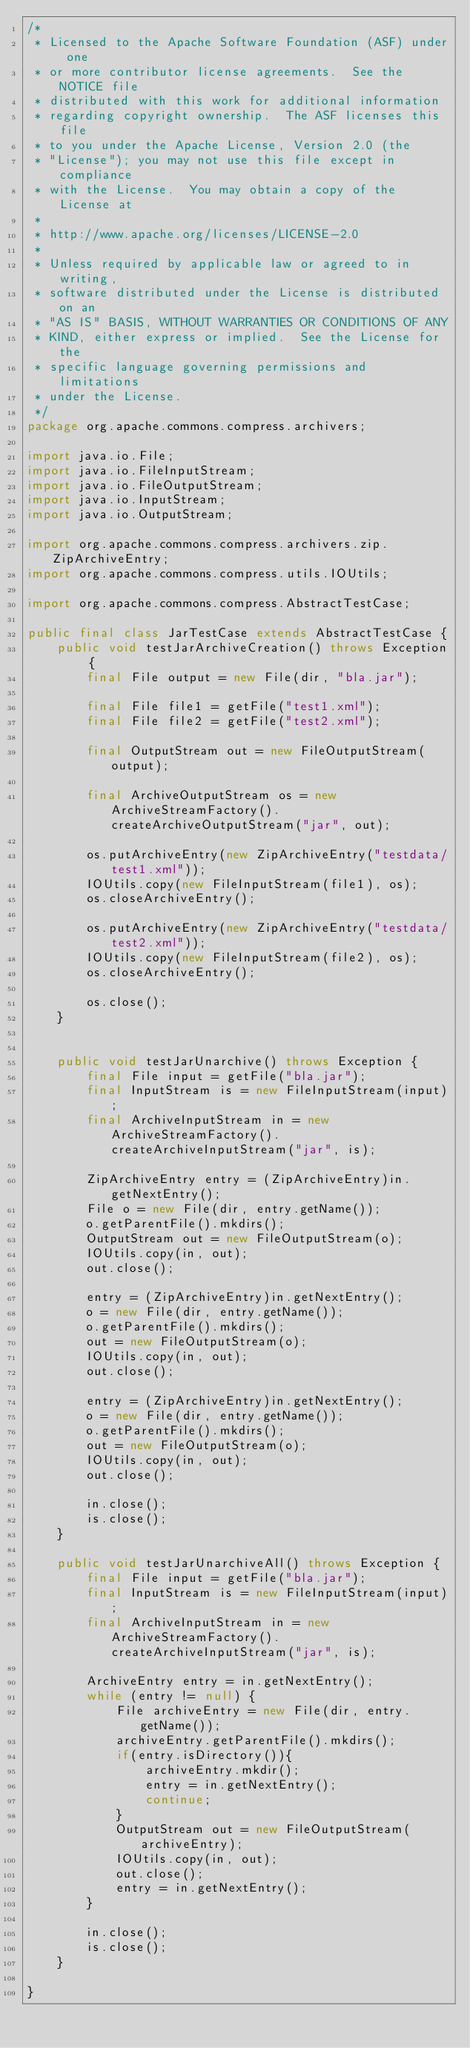<code> <loc_0><loc_0><loc_500><loc_500><_Java_>/*
 * Licensed to the Apache Software Foundation (ASF) under one
 * or more contributor license agreements.  See the NOTICE file
 * distributed with this work for additional information
 * regarding copyright ownership.  The ASF licenses this file
 * to you under the Apache License, Version 2.0 (the
 * "License"); you may not use this file except in compliance
 * with the License.  You may obtain a copy of the License at
 *
 * http://www.apache.org/licenses/LICENSE-2.0
 *
 * Unless required by applicable law or agreed to in writing,
 * software distributed under the License is distributed on an
 * "AS IS" BASIS, WITHOUT WARRANTIES OR CONDITIONS OF ANY
 * KIND, either express or implied.  See the License for the
 * specific language governing permissions and limitations
 * under the License.
 */
package org.apache.commons.compress.archivers;

import java.io.File;
import java.io.FileInputStream;
import java.io.FileOutputStream;
import java.io.InputStream;
import java.io.OutputStream;

import org.apache.commons.compress.archivers.zip.ZipArchiveEntry;
import org.apache.commons.compress.utils.IOUtils;

import org.apache.commons.compress.AbstractTestCase;

public final class JarTestCase extends AbstractTestCase {
	public void testJarArchiveCreation() throws Exception {
		final File output = new File(dir, "bla.jar");

		final File file1 = getFile("test1.xml");
		final File file2 = getFile("test2.xml");
		
        final OutputStream out = new FileOutputStream(output);
        
        final ArchiveOutputStream os = new ArchiveStreamFactory().createArchiveOutputStream("jar", out);

        os.putArchiveEntry(new ZipArchiveEntry("testdata/test1.xml"));
        IOUtils.copy(new FileInputStream(file1), os);
        os.closeArchiveEntry();
        
        os.putArchiveEntry(new ZipArchiveEntry("testdata/test2.xml"));
        IOUtils.copy(new FileInputStream(file2), os);
        os.closeArchiveEntry();

        os.close();
    }

	
	public void testJarUnarchive() throws Exception {
		final File input = getFile("bla.jar");
        final InputStream is = new FileInputStream(input);
        final ArchiveInputStream in = new ArchiveStreamFactory().createArchiveInputStream("jar", is);
        
        ZipArchiveEntry entry = (ZipArchiveEntry)in.getNextEntry();
        File o = new File(dir, entry.getName());
        o.getParentFile().mkdirs();
        OutputStream out = new FileOutputStream(o);
        IOUtils.copy(in, out);
        out.close();
        
        entry = (ZipArchiveEntry)in.getNextEntry();
        o = new File(dir, entry.getName());
        o.getParentFile().mkdirs();
        out = new FileOutputStream(o);
        IOUtils.copy(in, out);
        out.close();
        
        entry = (ZipArchiveEntry)in.getNextEntry();
        o = new File(dir, entry.getName());
        o.getParentFile().mkdirs();
        out = new FileOutputStream(o);
        IOUtils.copy(in, out);
        out.close();
        
        in.close();
        is.close();
    }
	
	public void testJarUnarchiveAll() throws Exception {
		final File input = getFile("bla.jar");
        final InputStream is = new FileInputStream(input);
        final ArchiveInputStream in = new ArchiveStreamFactory().createArchiveInputStream("jar", is);
        
        ArchiveEntry entry = in.getNextEntry();
		while (entry != null) {
			File archiveEntry = new File(dir, entry.getName());
			archiveEntry.getParentFile().mkdirs();
			if(entry.isDirectory()){
				archiveEntry.mkdir();
				entry = in.getNextEntry();
				continue;
			}
			OutputStream out = new FileOutputStream(archiveEntry);
			IOUtils.copy(in, out);
			out.close();
			entry = in.getNextEntry();
		}
		
		in.close();
		is.close();
	}

}
</code> 